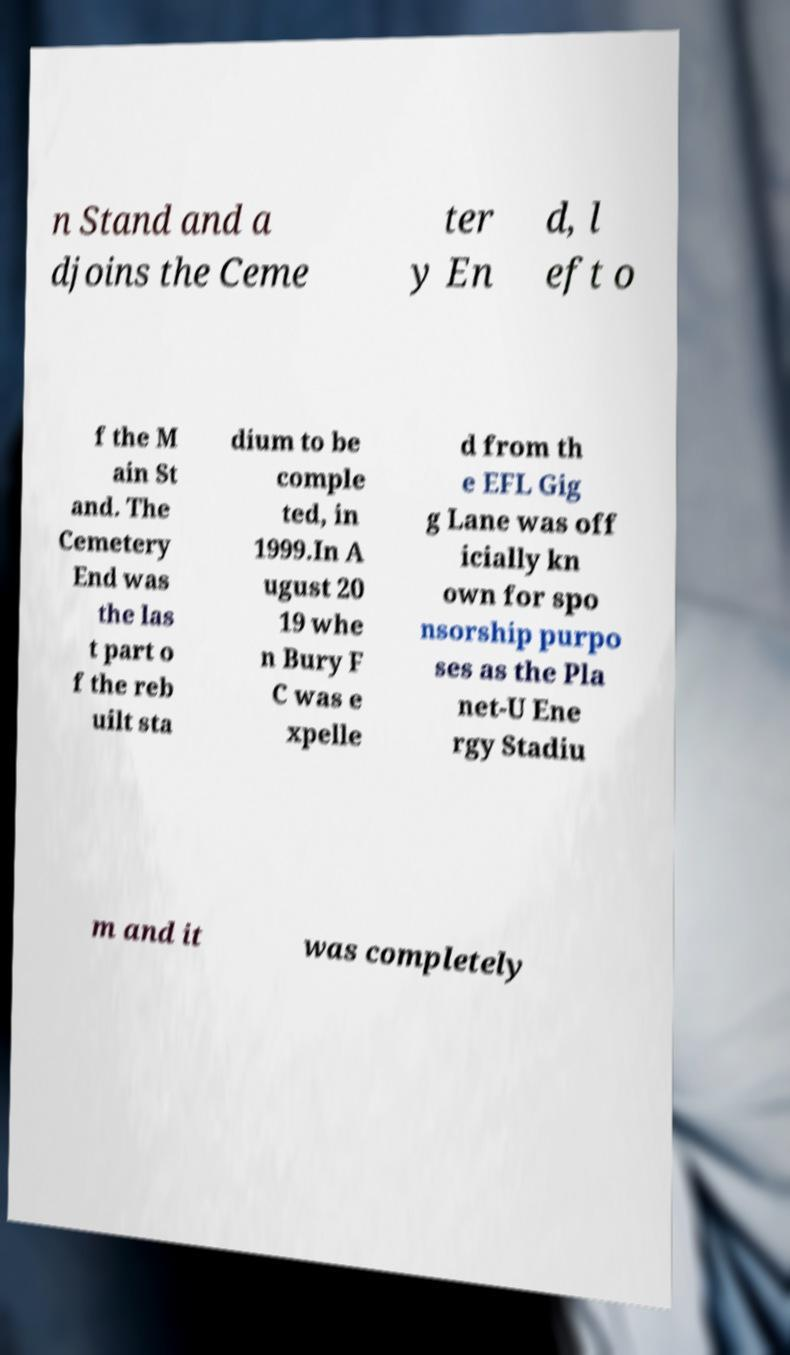There's text embedded in this image that I need extracted. Can you transcribe it verbatim? n Stand and a djoins the Ceme ter y En d, l eft o f the M ain St and. The Cemetery End was the las t part o f the reb uilt sta dium to be comple ted, in 1999.In A ugust 20 19 whe n Bury F C was e xpelle d from th e EFL Gig g Lane was off icially kn own for spo nsorship purpo ses as the Pla net-U Ene rgy Stadiu m and it was completely 